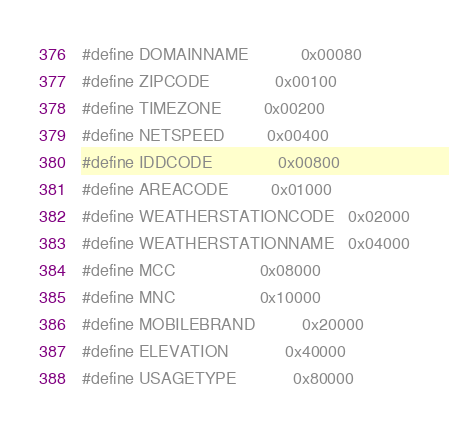<code> <loc_0><loc_0><loc_500><loc_500><_C_>#define DOMAINNAME			0x00080
#define ZIPCODE				0x00100
#define TIMEZONE			0x00200
#define NETSPEED			0x00400
#define IDDCODE				0x00800
#define AREACODE			0x01000
#define WEATHERSTATIONCODE	0x02000
#define WEATHERSTATIONNAME	0x04000
#define MCC					0x08000
#define MNC					0x10000
#define MOBILEBRAND			0x20000
#define ELEVATION			0x40000
#define USAGETYPE			0x80000</code> 